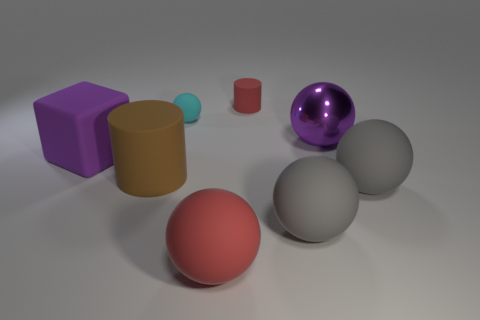Subtract 2 balls. How many balls are left? 3 Subtract all blue spheres. Subtract all cyan blocks. How many spheres are left? 5 Add 2 big blue cubes. How many objects exist? 10 Subtract all spheres. How many objects are left? 3 Add 2 big brown matte objects. How many big brown matte objects exist? 3 Subtract 0 brown blocks. How many objects are left? 8 Subtract all large cyan rubber objects. Subtract all balls. How many objects are left? 3 Add 1 brown cylinders. How many brown cylinders are left? 2 